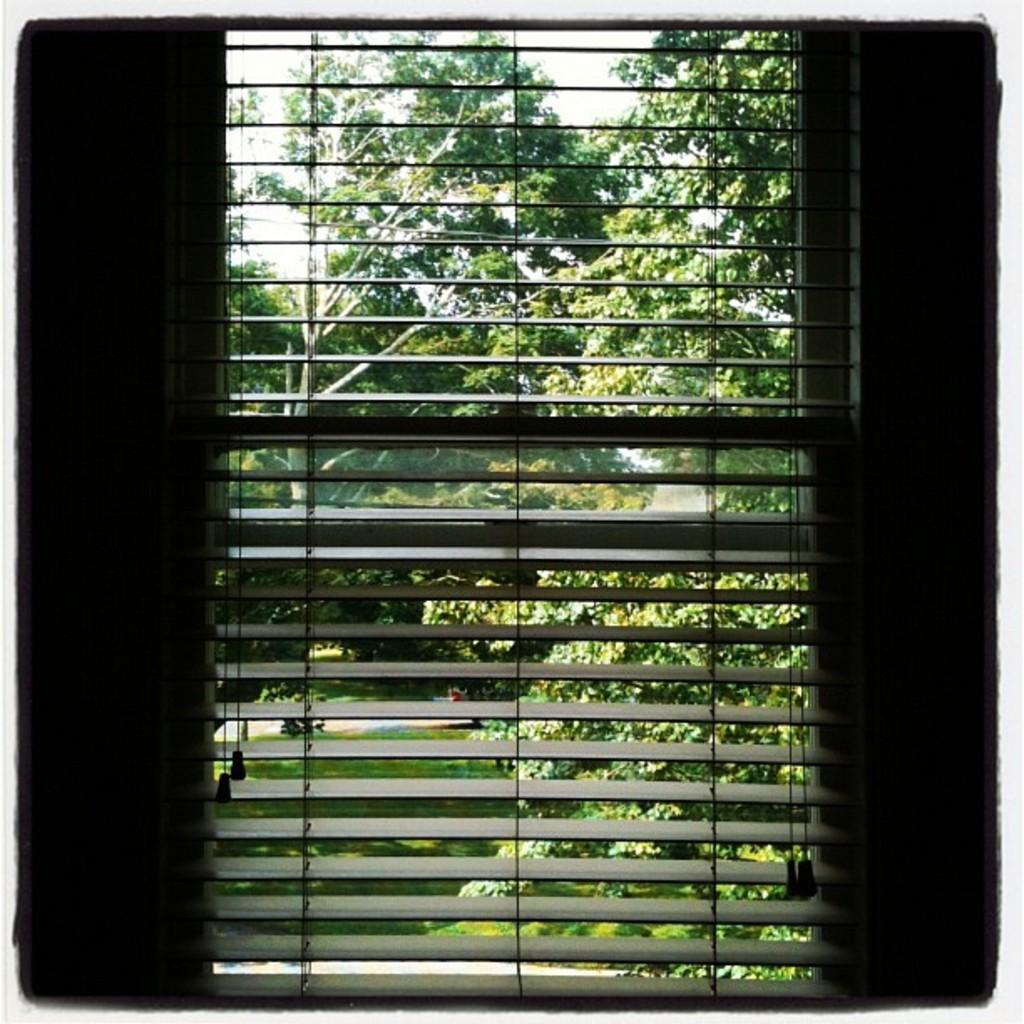What can be seen through the window in the image? Many trees are visible behind the window in the image. What is on the ground in the image? There is grass on the ground. Can you describe the natural environment in the image? The natural environment includes trees and grass. What type of coal can be seen in the image? There is no coal present in the image. Is there a chain visible in the image? There is no chain visible in the image. 